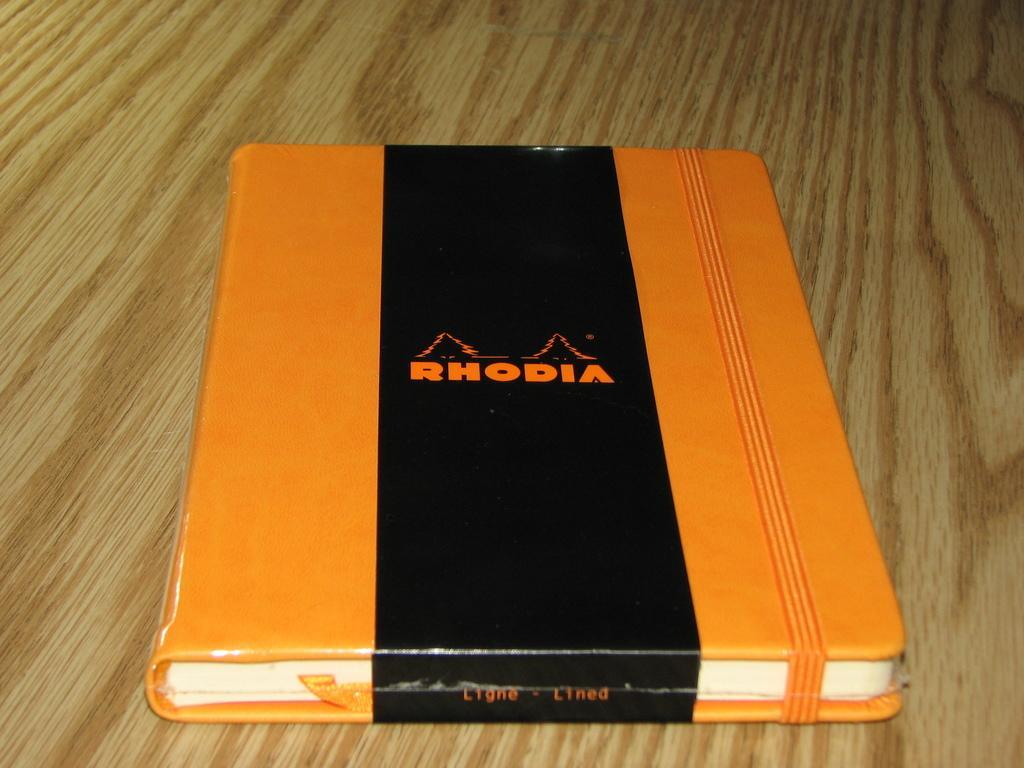<image>
Give a short and clear explanation of the subsequent image. A sealed Rhodia journal with an orange cover is laying on a wooden table. 